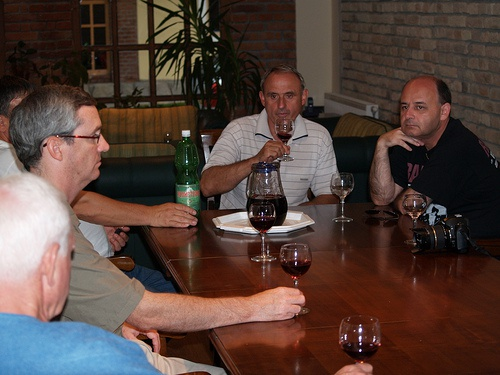Describe the objects in this image and their specific colors. I can see dining table in black, maroon, gray, and brown tones, people in black, gray, and salmon tones, people in black, lightblue, lightgray, lightpink, and gray tones, people in black, maroon, and brown tones, and potted plant in black, olive, and gray tones in this image. 